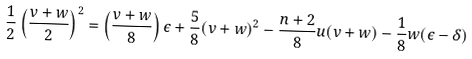Convert formula to latex. <formula><loc_0><loc_0><loc_500><loc_500>\frac { 1 } { 2 } \left ( \frac { v + w } { 2 } \right ) ^ { 2 } = \left ( \frac { v + w } { 8 } \right ) \epsilon + \frac { 5 } { 8 } ( v + w ) ^ { 2 } - \frac { n + 2 } { 8 } u ( v + w ) - \frac { 1 } { 8 } w ( \epsilon - \delta )</formula> 